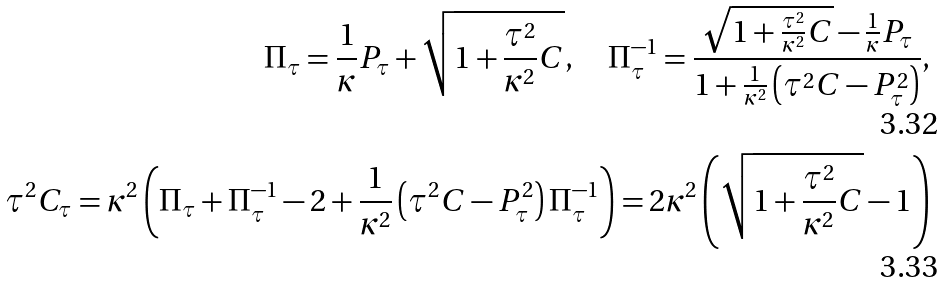<formula> <loc_0><loc_0><loc_500><loc_500>\Pi _ { \tau } = \frac { 1 } { \kappa } P _ { \tau } + \sqrt { 1 + \frac { \tau ^ { 2 } } { \kappa ^ { 2 } } C } , \quad \Pi _ { \tau } ^ { - 1 } = \frac { \sqrt { 1 + \frac { \tau ^ { 2 } } { \kappa ^ { 2 } } C } - \frac { 1 } { \kappa } P _ { \tau } } { 1 + \frac { 1 } { \kappa ^ { 2 } } \left ( \tau ^ { 2 } C - P _ { \tau } ^ { 2 } \right ) } , \\ \tau ^ { 2 } C _ { \tau } = \kappa ^ { 2 } \left ( \Pi _ { \tau } + \Pi _ { \tau } ^ { - 1 } - 2 + \frac { 1 } { \kappa ^ { 2 } } \left ( \tau ^ { 2 } C - P _ { \tau } ^ { 2 } \right ) \Pi _ { \tau } ^ { - 1 } \right ) = 2 \kappa ^ { 2 } \left ( \sqrt { 1 + \frac { \tau ^ { 2 } } { \kappa ^ { 2 } } C } - 1 \right )</formula> 